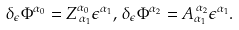Convert formula to latex. <formula><loc_0><loc_0><loc_500><loc_500>\delta _ { \epsilon } \Phi ^ { \alpha _ { 0 } } = Z _ { \, \alpha _ { 1 } } ^ { \alpha _ { 0 } } \epsilon ^ { \alpha _ { 1 } } , \, \delta _ { \epsilon } \Phi ^ { \alpha _ { 2 } } = A _ { \alpha _ { 1 } } ^ { \, \alpha _ { 2 } } \epsilon ^ { \alpha _ { 1 } } .</formula> 